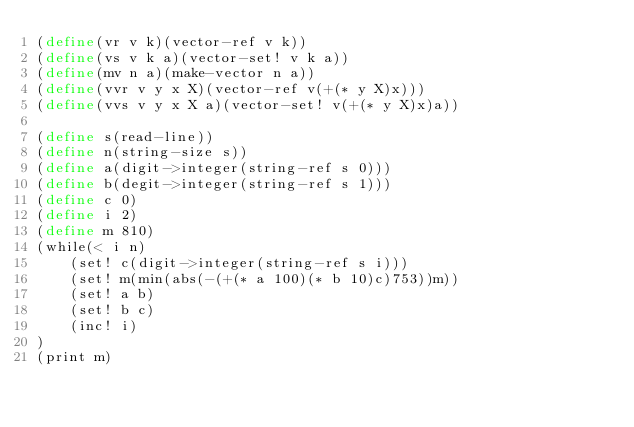Convert code to text. <code><loc_0><loc_0><loc_500><loc_500><_Scheme_>(define(vr v k)(vector-ref v k))
(define(vs v k a)(vector-set! v k a))
(define(mv n a)(make-vector n a))
(define(vvr v y x X)(vector-ref v(+(* y X)x)))
(define(vvs v y x X a)(vector-set! v(+(* y X)x)a))

(define s(read-line))
(define n(string-size s))
(define a(digit->integer(string-ref s 0)))
(define b(degit->integer(string-ref s 1)))
(define c 0)
(define i 2)
(define m 810)
(while(< i n)
	(set! c(digit->integer(string-ref s i)))
	(set! m(min(abs(-(+(* a 100)(* b 10)c)753))m))
	(set! a b)
	(set! b c)
	(inc! i)
)
(print m)</code> 